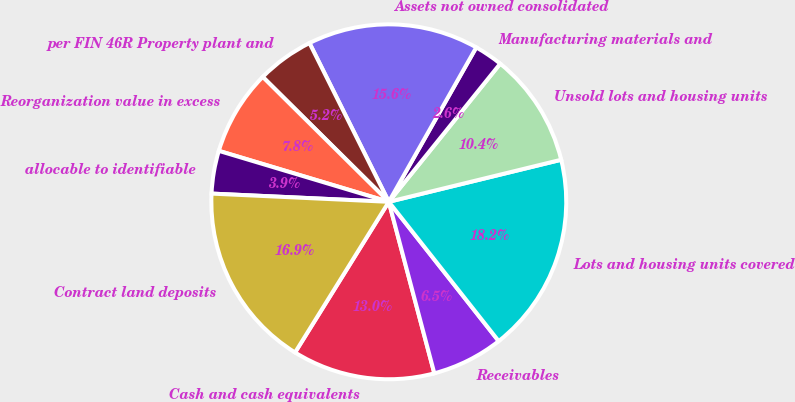<chart> <loc_0><loc_0><loc_500><loc_500><pie_chart><fcel>Cash and cash equivalents<fcel>Receivables<fcel>Lots and housing units covered<fcel>Unsold lots and housing units<fcel>Manufacturing materials and<fcel>Assets not owned consolidated<fcel>per FIN 46R Property plant and<fcel>Reorganization value in excess<fcel>allocable to identifiable<fcel>Contract land deposits<nl><fcel>12.99%<fcel>6.5%<fcel>18.18%<fcel>10.39%<fcel>2.6%<fcel>15.58%<fcel>5.2%<fcel>7.79%<fcel>3.9%<fcel>16.88%<nl></chart> 